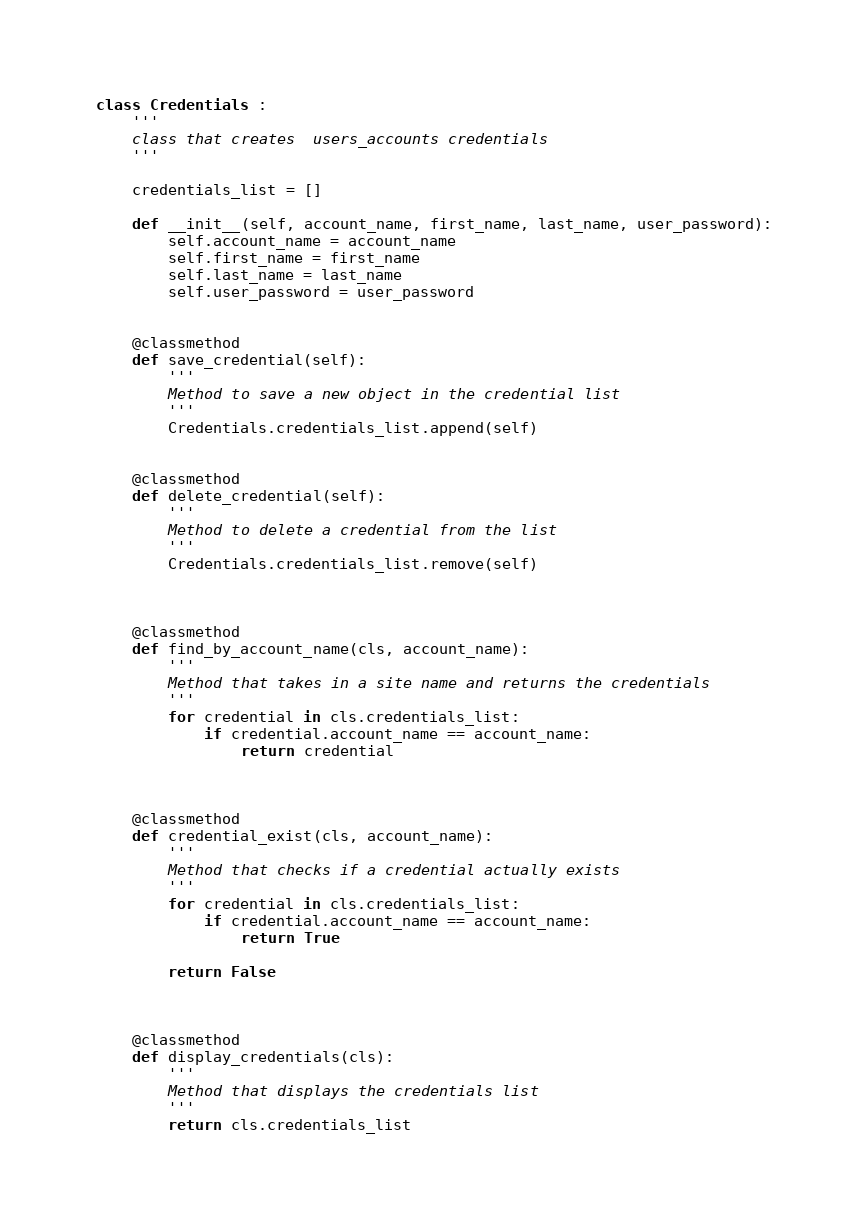<code> <loc_0><loc_0><loc_500><loc_500><_Python_>class Credentials :
    '''
    class that creates  users_accounts credentials
    '''

    credentials_list = [] 

    def __init__(self, account_name, first_name, last_name, user_password):
        self.account_name = account_name
        self.first_name = first_name
        self.last_name = last_name
        self.user_password = user_password


    @classmethod
    def save_credential(self):
        '''
        Method to save a new object in the credential list
        '''
        Credentials.credentials_list.append(self)


    @classmethod
    def delete_credential(self):
        '''
        Method to delete a credential from the list
        '''
        Credentials.credentials_list.remove(self)

    

    @classmethod
    def find_by_account_name(cls, account_name):
        '''
        Method that takes in a site name and returns the credentials
        '''
        for credential in cls.credentials_list:
            if credential.account_name == account_name:
                return credential



    @classmethod
    def credential_exist(cls, account_name):
        '''
        Method that checks if a credential actually exists
        '''
        for credential in cls.credentials_list:
            if credential.account_name == account_name:
                return True

        return False



    @classmethod
    def display_credentials(cls):
        '''
        Method that displays the credentials list
        '''
        return cls.credentials_list




</code> 